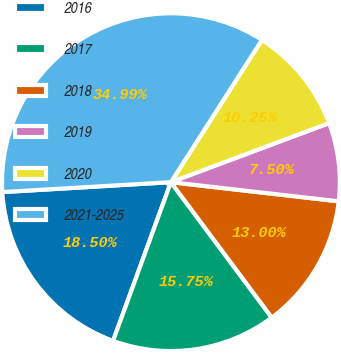Convert chart. <chart><loc_0><loc_0><loc_500><loc_500><pie_chart><fcel>2016<fcel>2017<fcel>2018<fcel>2019<fcel>2020<fcel>2021-2025<nl><fcel>18.5%<fcel>15.75%<fcel>13.0%<fcel>7.5%<fcel>10.25%<fcel>34.99%<nl></chart> 